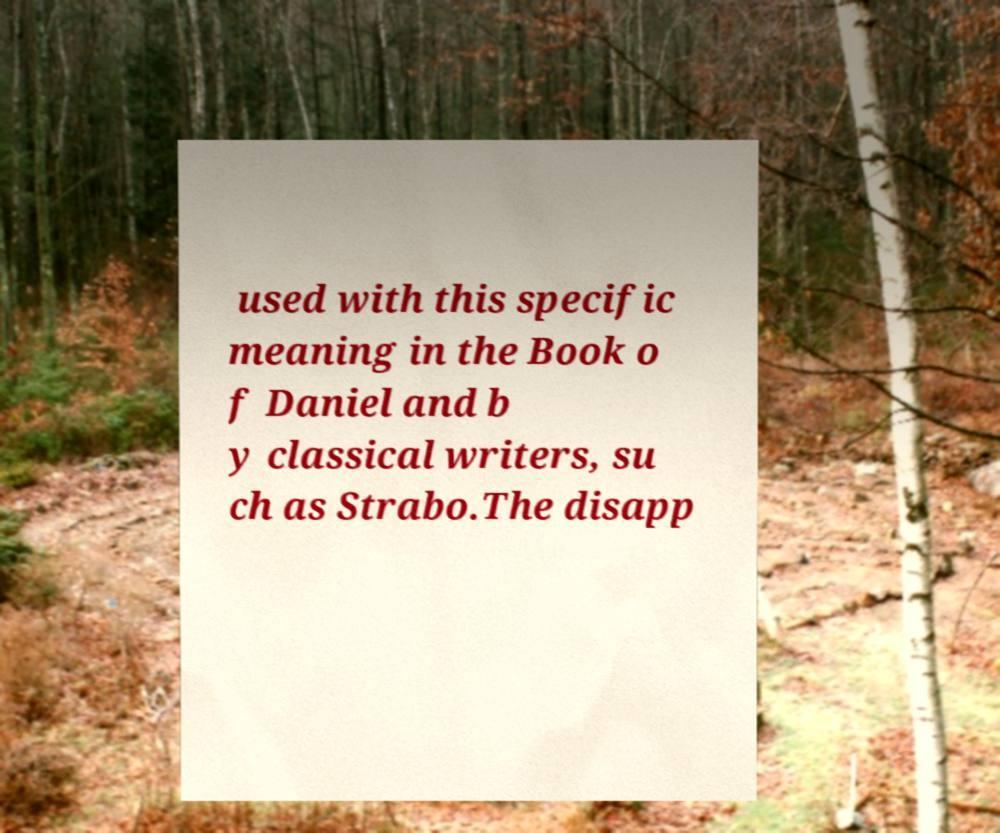Could you assist in decoding the text presented in this image and type it out clearly? used with this specific meaning in the Book o f Daniel and b y classical writers, su ch as Strabo.The disapp 